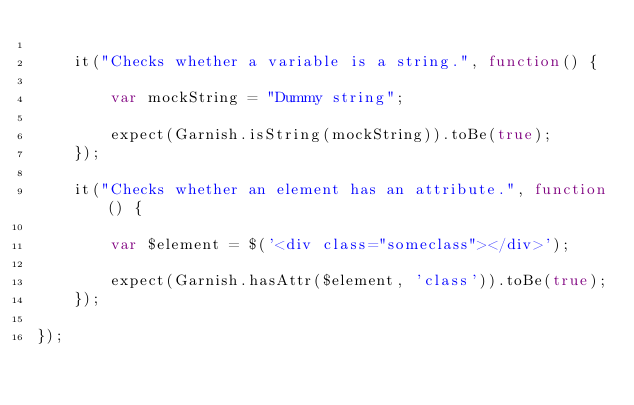Convert code to text. <code><loc_0><loc_0><loc_500><loc_500><_JavaScript_>
	it("Checks whether a variable is a string.", function() {

		var mockString = "Dummy string";

		expect(Garnish.isString(mockString)).toBe(true);
	});

	it("Checks whether an element has an attribute.", function() {

		var $element = $('<div class="someclass"></div>');

		expect(Garnish.hasAttr($element, 'class')).toBe(true);
	});

});</code> 